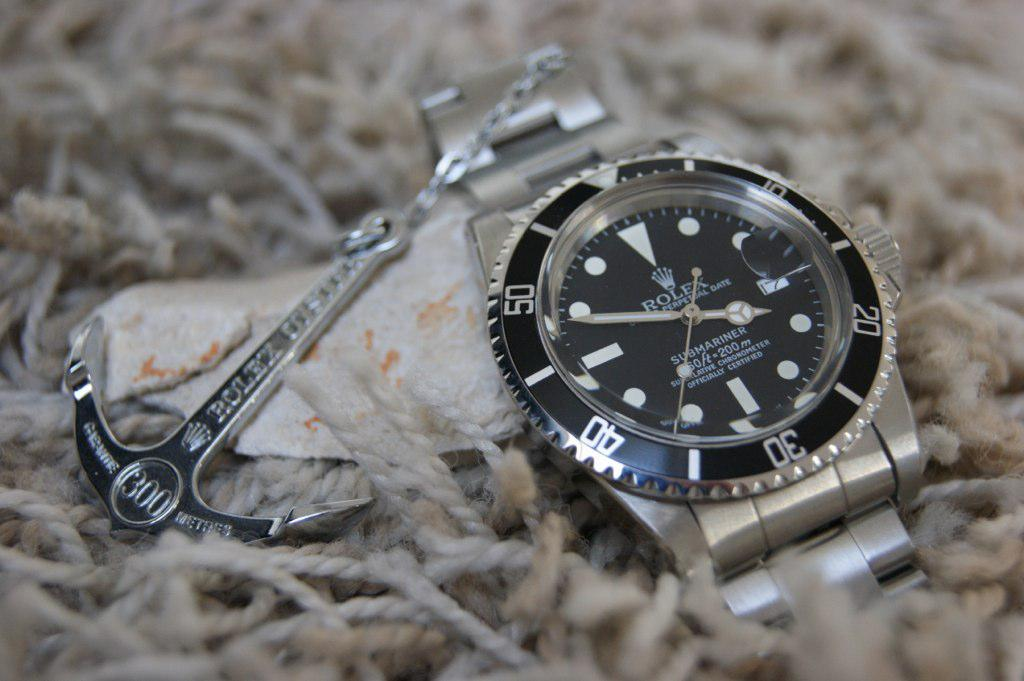<image>
Give a short and clear explanation of the subsequent image. a rolex submariner watch that is offically certified 